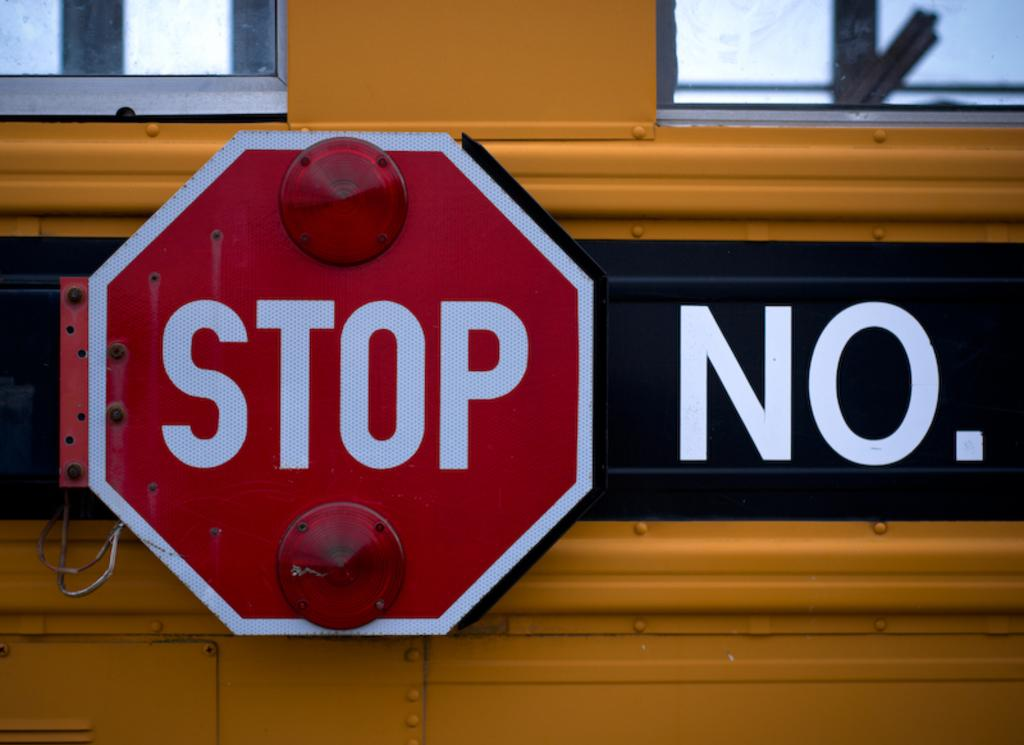<image>
Summarize the visual content of the image. The stop sign attached to a bus is located next to the bus' number. 